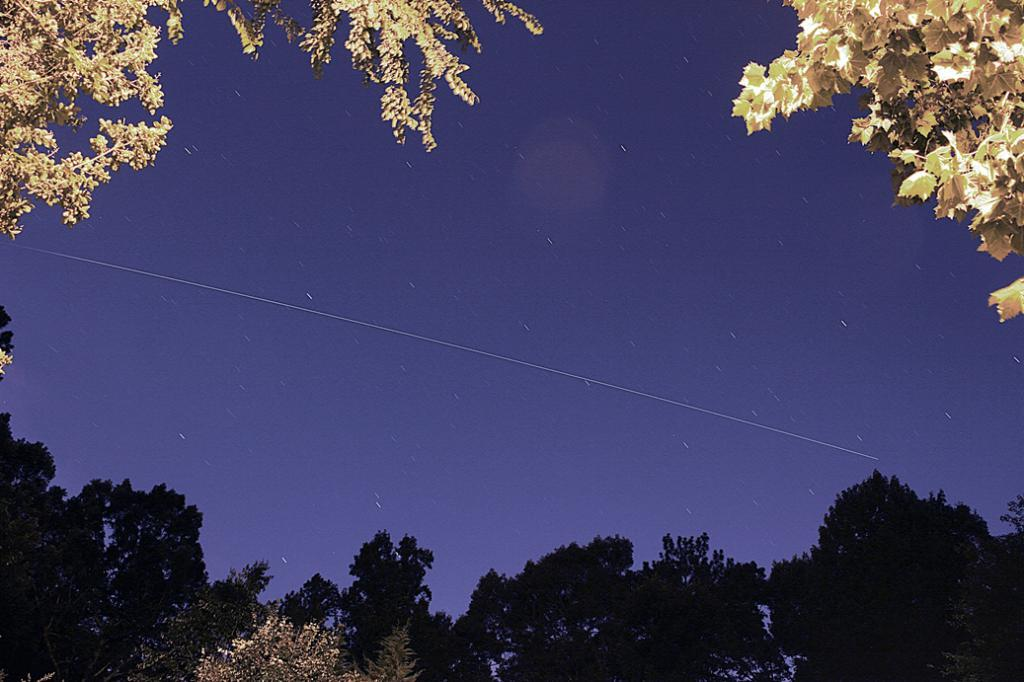What is the time of day depicted in the image? The image depicts a night view of the sky. What celestial event can be seen in the sky? There is a shooting star in the sky. What type of vegetation is visible at the bottom of the image? There are trees visible at the bottom of the image. What type of guide can be seen leading a group of people in the image? There is no guide or group of people present in the image; it depicts a night view of the sky with a shooting star and trees. 